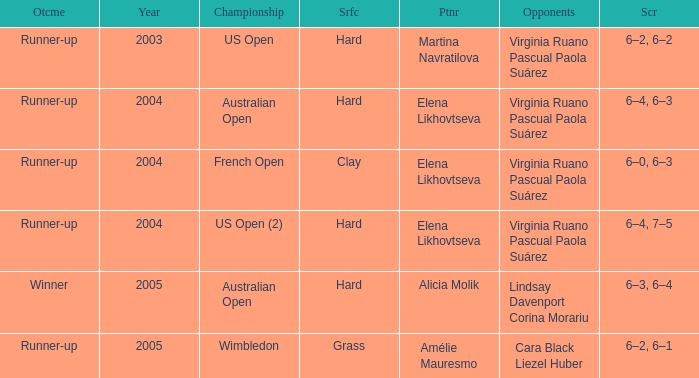When Australian open is the championship what is the lowest year? 2004.0. 